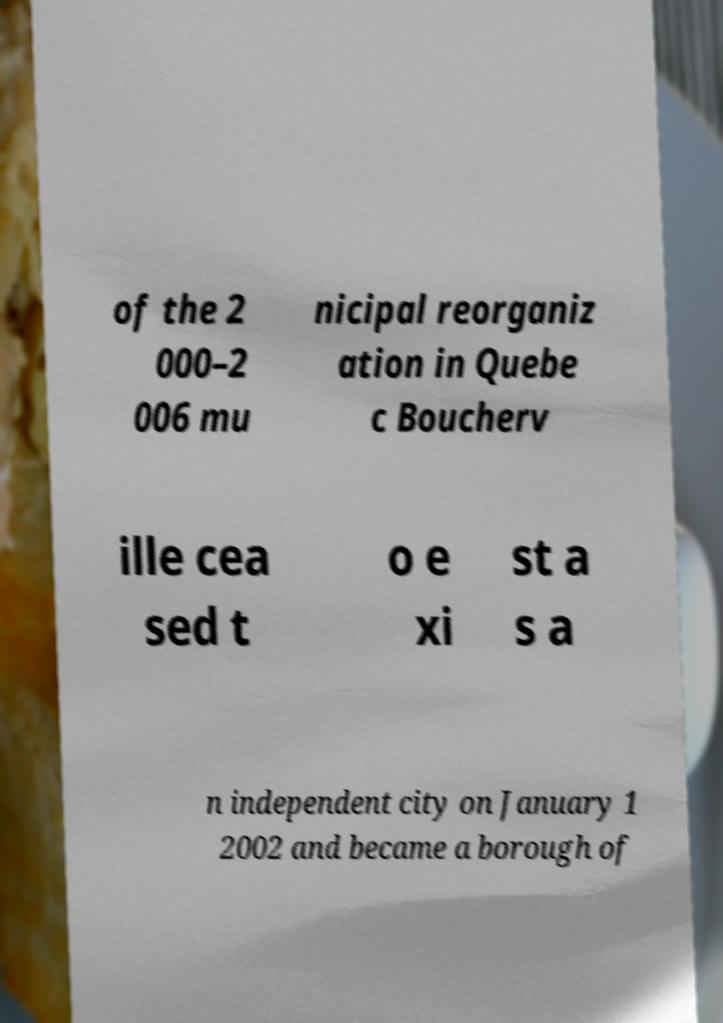For documentation purposes, I need the text within this image transcribed. Could you provide that? of the 2 000–2 006 mu nicipal reorganiz ation in Quebe c Boucherv ille cea sed t o e xi st a s a n independent city on January 1 2002 and became a borough of 